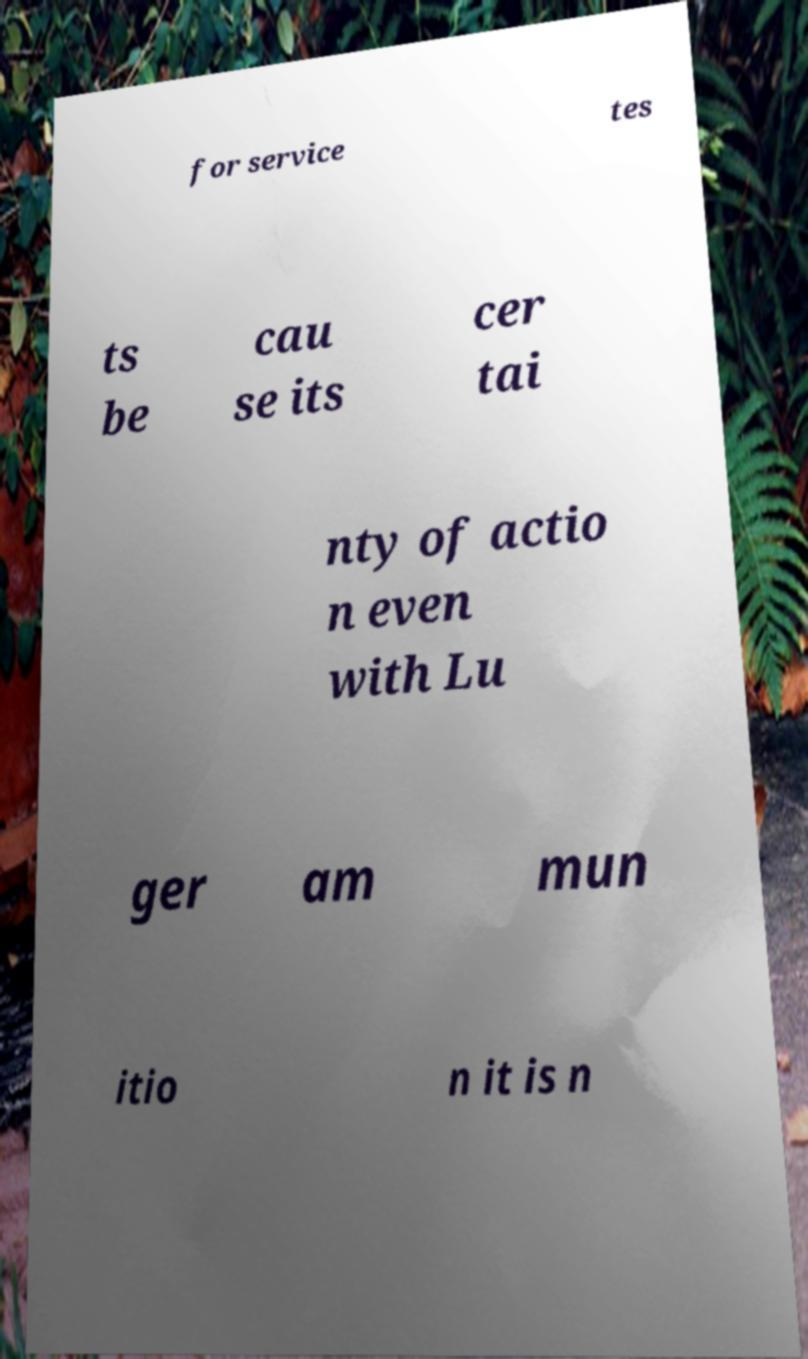What messages or text are displayed in this image? I need them in a readable, typed format. for service tes ts be cau se its cer tai nty of actio n even with Lu ger am mun itio n it is n 